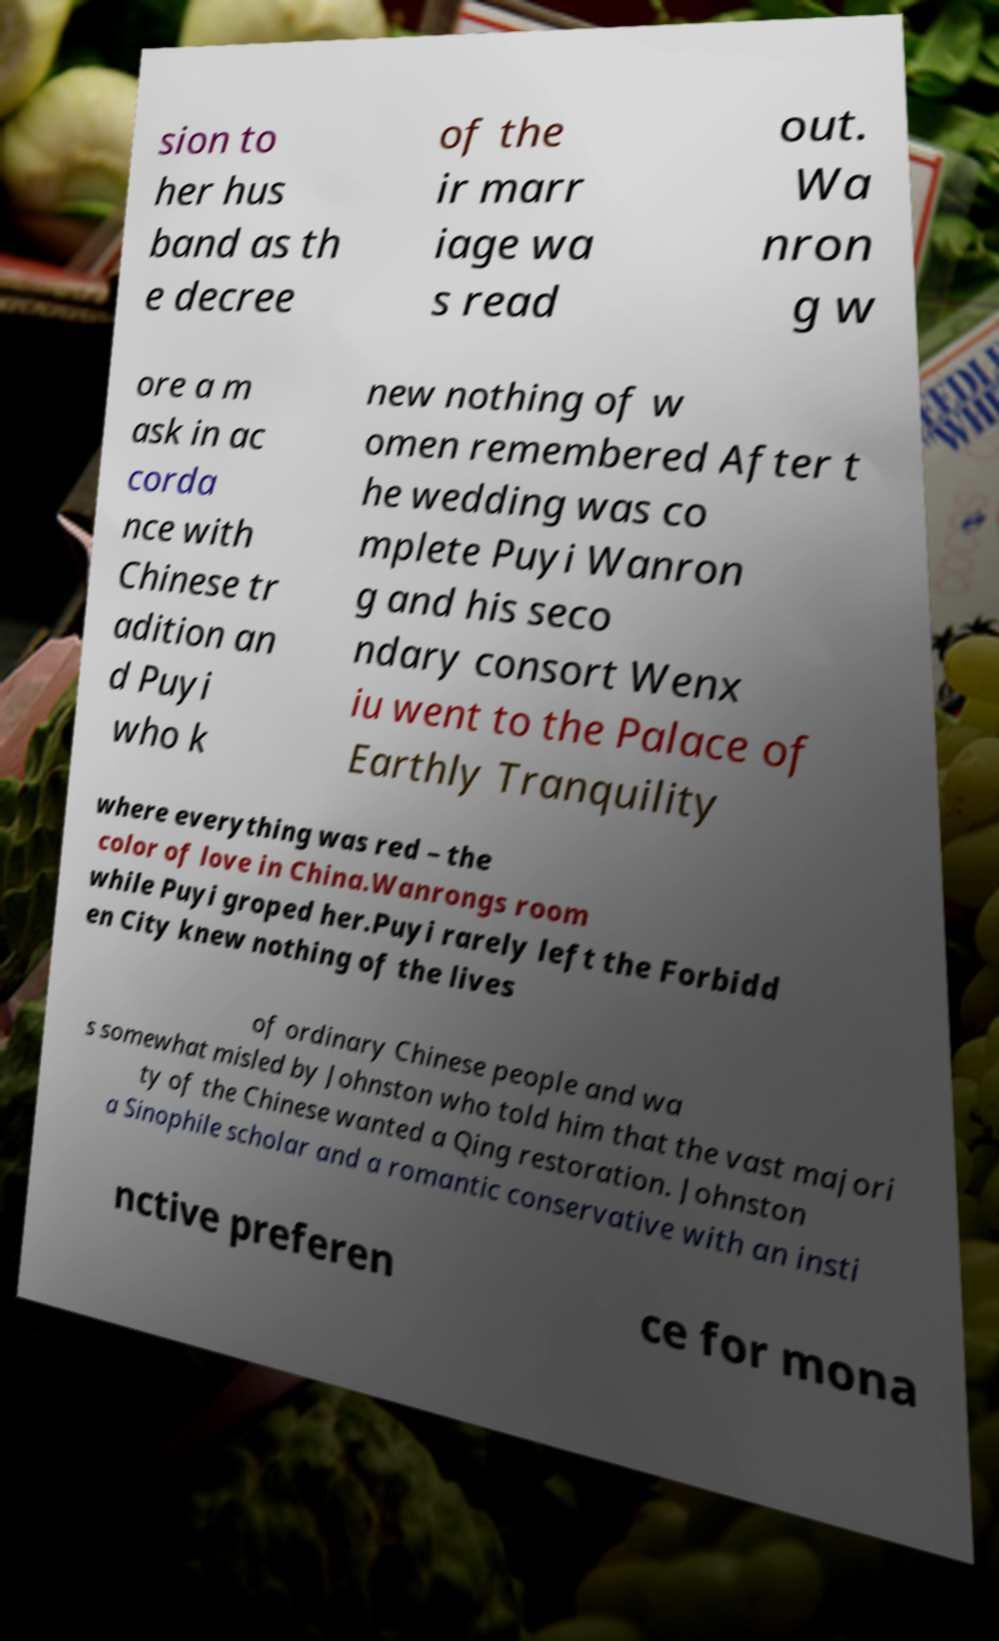Could you assist in decoding the text presented in this image and type it out clearly? sion to her hus band as th e decree of the ir marr iage wa s read out. Wa nron g w ore a m ask in ac corda nce with Chinese tr adition an d Puyi who k new nothing of w omen remembered After t he wedding was co mplete Puyi Wanron g and his seco ndary consort Wenx iu went to the Palace of Earthly Tranquility where everything was red – the color of love in China.Wanrongs room while Puyi groped her.Puyi rarely left the Forbidd en City knew nothing of the lives of ordinary Chinese people and wa s somewhat misled by Johnston who told him that the vast majori ty of the Chinese wanted a Qing restoration. Johnston a Sinophile scholar and a romantic conservative with an insti nctive preferen ce for mona 